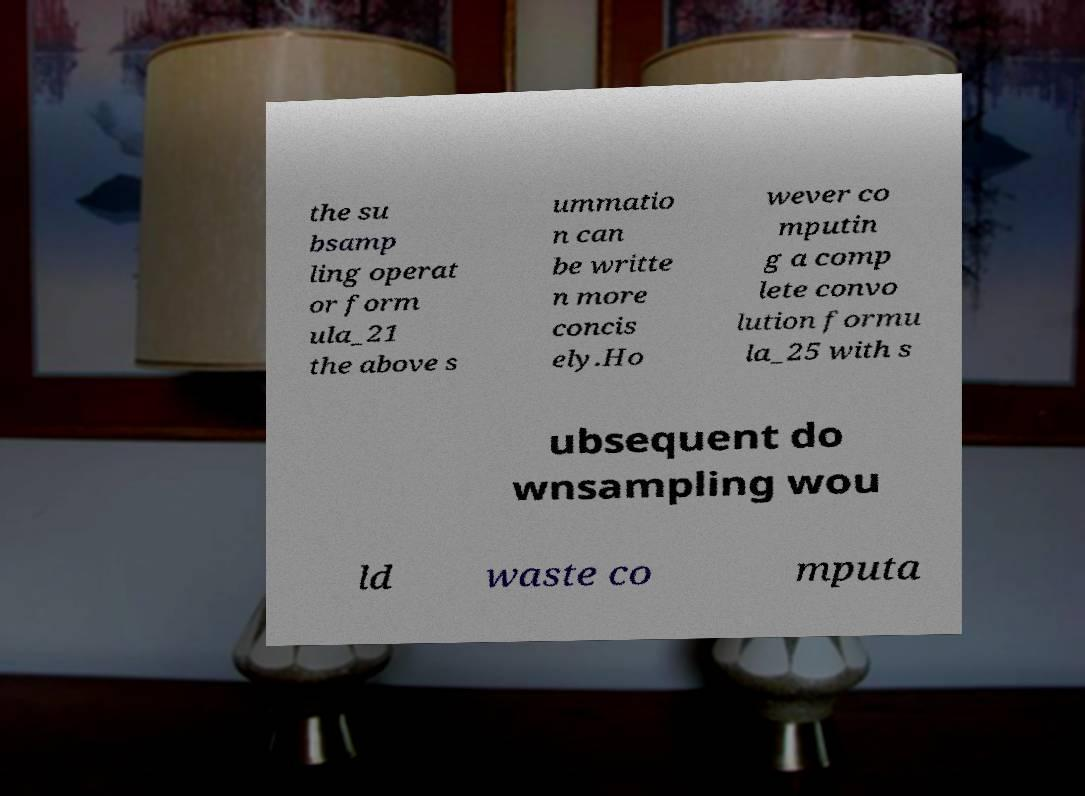Can you read and provide the text displayed in the image?This photo seems to have some interesting text. Can you extract and type it out for me? the su bsamp ling operat or form ula_21 the above s ummatio n can be writte n more concis ely.Ho wever co mputin g a comp lete convo lution formu la_25 with s ubsequent do wnsampling wou ld waste co mputa 